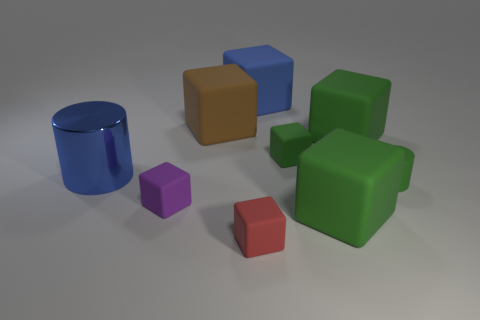There is a matte thing that is both in front of the big blue shiny cylinder and behind the tiny purple block; what color is it?
Provide a short and direct response. Green. Are there fewer small things than tiny gray rubber cubes?
Offer a terse response. No. There is a metal cylinder; is it the same color as the large object that is behind the brown rubber block?
Your response must be concise. Yes. Is the number of small green rubber objects that are in front of the blue cylinder the same as the number of blue metallic cylinders that are right of the brown matte thing?
Provide a short and direct response. No. What number of green objects are the same shape as the red rubber thing?
Make the answer very short. 3. Are any tiny red rubber objects visible?
Your answer should be compact. Yes. Is the material of the brown thing the same as the blue object behind the brown thing?
Provide a short and direct response. Yes. There is a cylinder that is the same size as the brown cube; what is its material?
Provide a short and direct response. Metal. Is there a red block that has the same material as the small green cylinder?
Provide a succinct answer. Yes. There is a large blue object in front of the blue thing behind the brown rubber thing; are there any small green objects that are left of it?
Provide a succinct answer. No. 